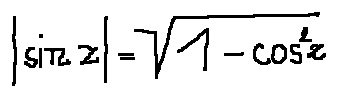<formula> <loc_0><loc_0><loc_500><loc_500>| \sin z | = \sqrt { 1 - \cos ^ { 2 } z }</formula> 